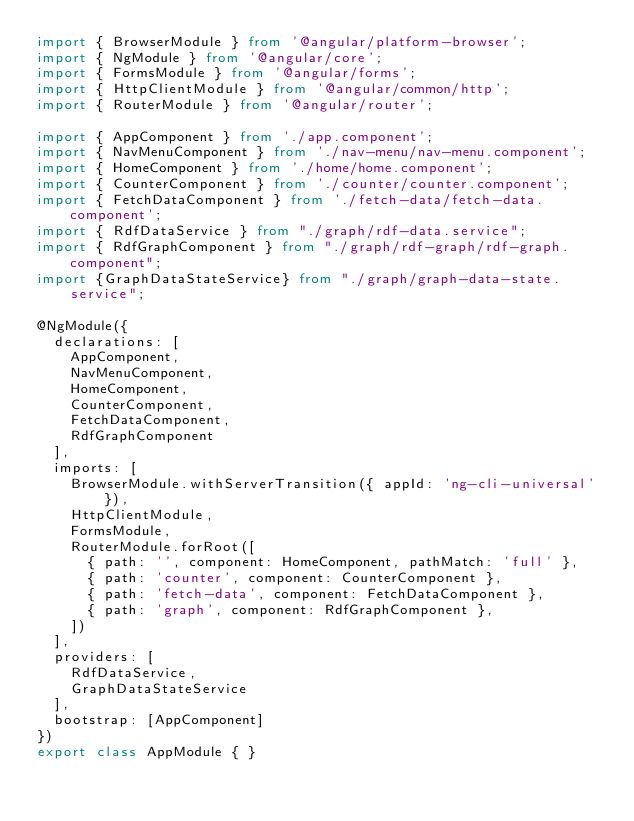Convert code to text. <code><loc_0><loc_0><loc_500><loc_500><_TypeScript_>import { BrowserModule } from '@angular/platform-browser';
import { NgModule } from '@angular/core';
import { FormsModule } from '@angular/forms';
import { HttpClientModule } from '@angular/common/http';
import { RouterModule } from '@angular/router';

import { AppComponent } from './app.component';
import { NavMenuComponent } from './nav-menu/nav-menu.component';
import { HomeComponent } from './home/home.component';
import { CounterComponent } from './counter/counter.component';
import { FetchDataComponent } from './fetch-data/fetch-data.component';
import { RdfDataService } from "./graph/rdf-data.service";
import { RdfGraphComponent } from "./graph/rdf-graph/rdf-graph.component";
import {GraphDataStateService} from "./graph/graph-data-state.service";

@NgModule({
  declarations: [
    AppComponent,
    NavMenuComponent,
    HomeComponent,
    CounterComponent,
    FetchDataComponent,
    RdfGraphComponent
  ],
  imports: [
    BrowserModule.withServerTransition({ appId: 'ng-cli-universal' }),
    HttpClientModule,
    FormsModule,
    RouterModule.forRoot([
      { path: '', component: HomeComponent, pathMatch: 'full' },
      { path: 'counter', component: CounterComponent },
      { path: 'fetch-data', component: FetchDataComponent },
      { path: 'graph', component: RdfGraphComponent },
    ])
  ],
  providers: [
    RdfDataService,
    GraphDataStateService
  ],
  bootstrap: [AppComponent]
})
export class AppModule { }
</code> 